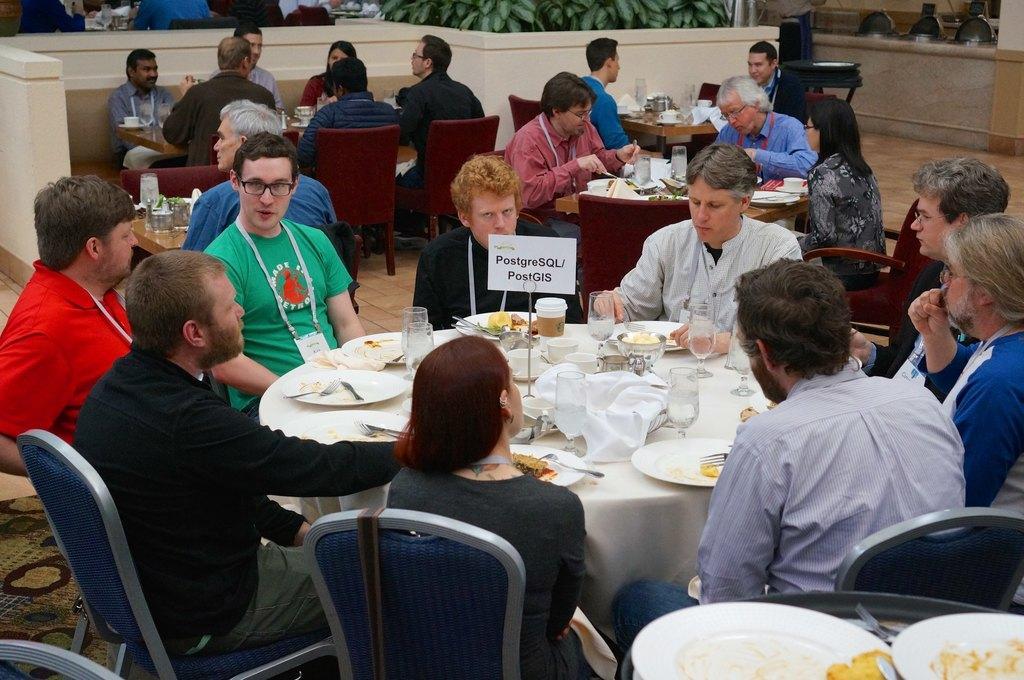Describe this image in one or two sentences. in a building there are tables. on a table in the front there is a white cloth on which there are plates, fork, glasses, cup, board. people are seated around the chairs on blue chairs. behind that there are 3 more table on which people are seated. at the back there are plants. 